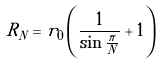Convert formula to latex. <formula><loc_0><loc_0><loc_500><loc_500>R _ { N } = r _ { 0 } \left ( \frac { 1 } { \sin \frac { \pi } { N } } + 1 \right )</formula> 